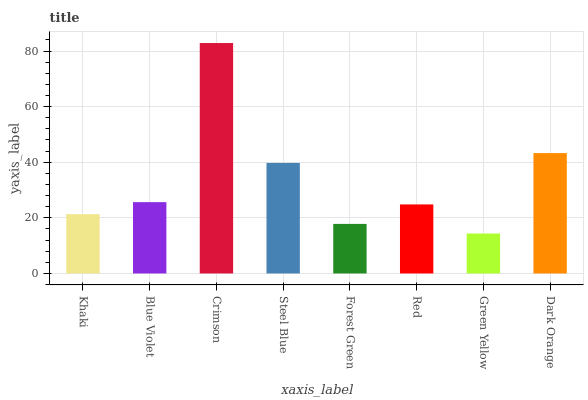Is Blue Violet the minimum?
Answer yes or no. No. Is Blue Violet the maximum?
Answer yes or no. No. Is Blue Violet greater than Khaki?
Answer yes or no. Yes. Is Khaki less than Blue Violet?
Answer yes or no. Yes. Is Khaki greater than Blue Violet?
Answer yes or no. No. Is Blue Violet less than Khaki?
Answer yes or no. No. Is Blue Violet the high median?
Answer yes or no. Yes. Is Red the low median?
Answer yes or no. Yes. Is Dark Orange the high median?
Answer yes or no. No. Is Khaki the low median?
Answer yes or no. No. 